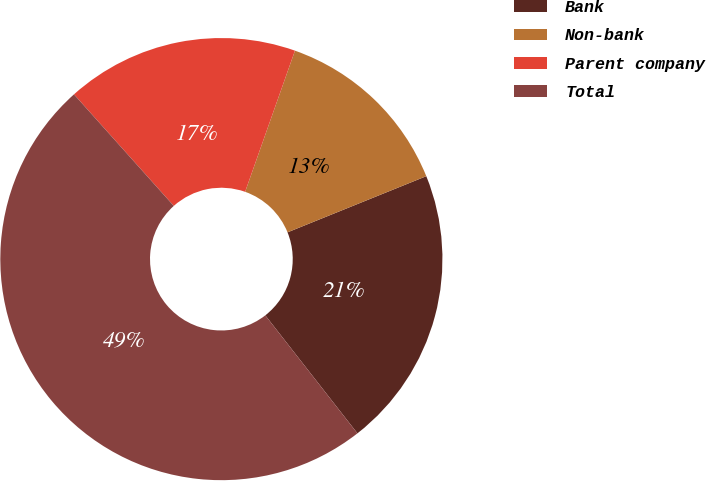Convert chart. <chart><loc_0><loc_0><loc_500><loc_500><pie_chart><fcel>Bank<fcel>Non-bank<fcel>Parent company<fcel>Total<nl><fcel>20.57%<fcel>13.48%<fcel>17.02%<fcel>48.94%<nl></chart> 